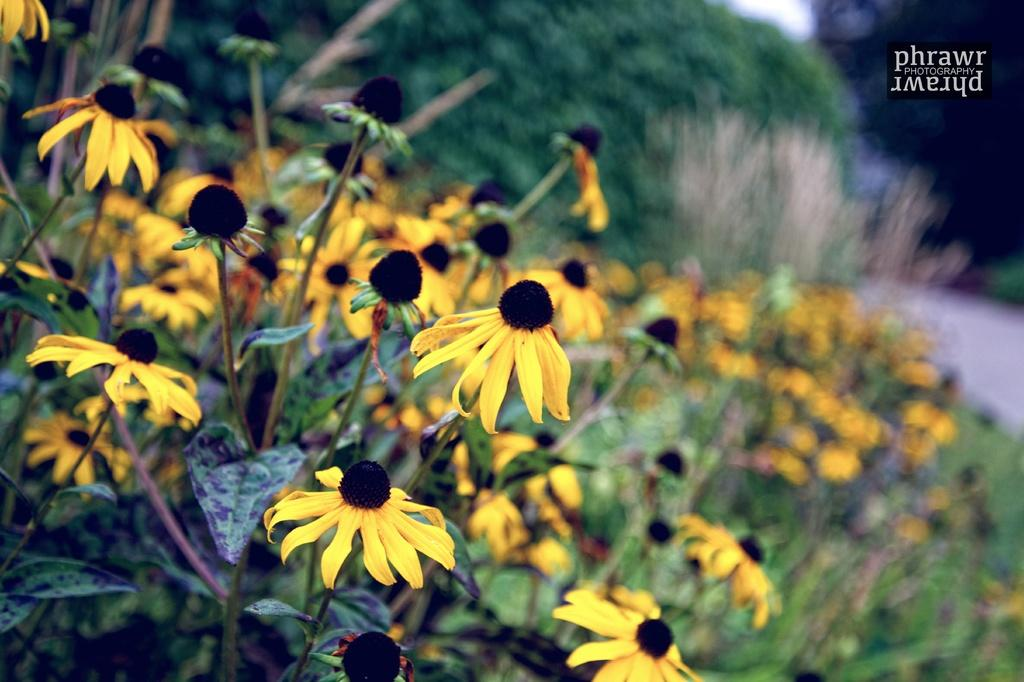What types of living organisms can be seen in the image? Plants and flowers are visible in the image. Can you describe the background of the image? The background of the image is blurred. Is there any text present in the image? Yes, there is text visible in the top right side of the image. Can you tell me how many snails are crawling on the stove in the image? There is no stove or snail present in the image. What color is the wristband on the wrist of the person in the image? There is no person or wristband visible in the image. 